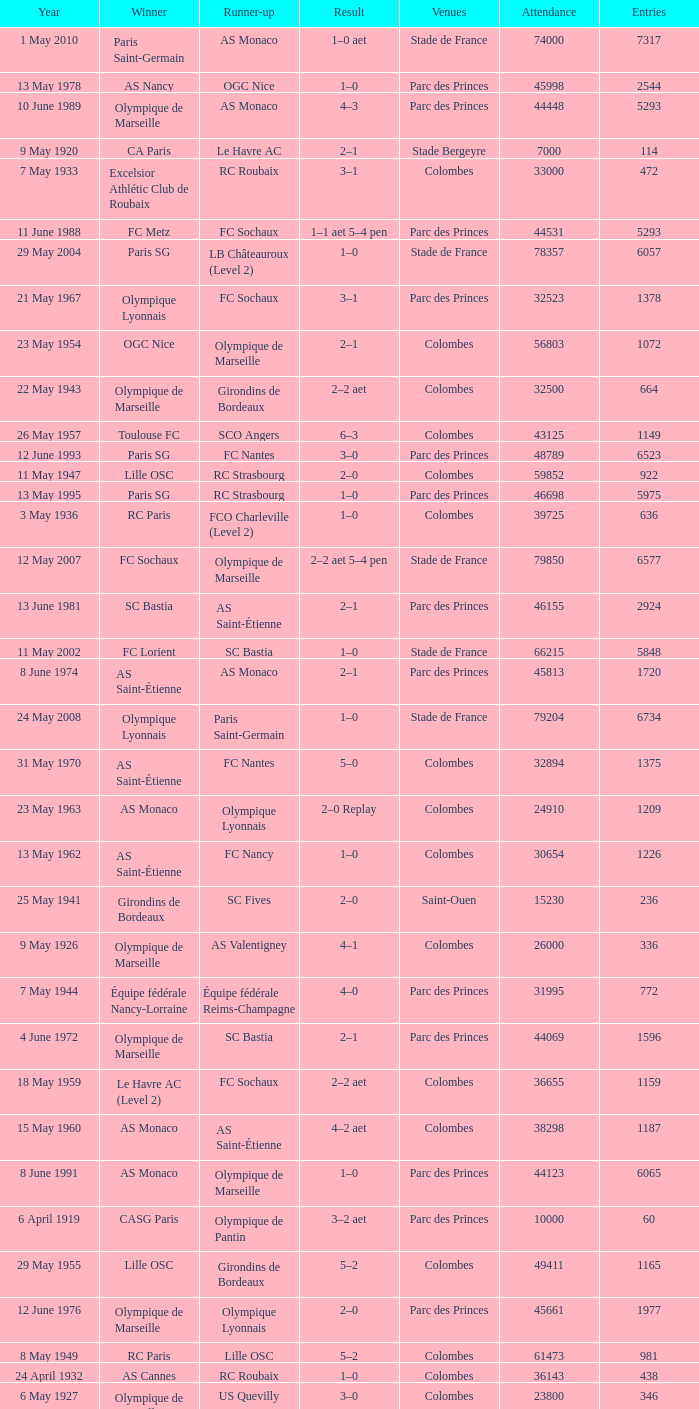Could you parse the entire table as a dict? {'header': ['Year', 'Winner', 'Runner-up', 'Result', 'Venues', 'Attendance', 'Entries'], 'rows': [['1 May 2010', 'Paris Saint-Germain', 'AS Monaco', '1–0 aet', 'Stade de France', '74000', '7317'], ['13 May 1978', 'AS Nancy', 'OGC Nice', '1–0', 'Parc des Princes', '45998', '2544'], ['10 June 1989', 'Olympique de Marseille', 'AS Monaco', '4–3', 'Parc des Princes', '44448', '5293'], ['9 May 1920', 'CA Paris', 'Le Havre AC', '2–1', 'Stade Bergeyre', '7000', '114'], ['7 May 1933', 'Excelsior Athlétic Club de Roubaix', 'RC Roubaix', '3–1', 'Colombes', '33000', '472'], ['11 June 1988', 'FC Metz', 'FC Sochaux', '1–1 aet 5–4 pen', 'Parc des Princes', '44531', '5293'], ['29 May 2004', 'Paris SG', 'LB Châteauroux (Level 2)', '1–0', 'Stade de France', '78357', '6057'], ['21 May 1967', 'Olympique Lyonnais', 'FC Sochaux', '3–1', 'Parc des Princes', '32523', '1378'], ['23 May 1954', 'OGC Nice', 'Olympique de Marseille', '2–1', 'Colombes', '56803', '1072'], ['22 May 1943', 'Olympique de Marseille', 'Girondins de Bordeaux', '2–2 aet', 'Colombes', '32500', '664'], ['26 May 1957', 'Toulouse FC', 'SCO Angers', '6–3', 'Colombes', '43125', '1149'], ['12 June 1993', 'Paris SG', 'FC Nantes', '3–0', 'Parc des Princes', '48789', '6523'], ['11 May 1947', 'Lille OSC', 'RC Strasbourg', '2–0', 'Colombes', '59852', '922'], ['13 May 1995', 'Paris SG', 'RC Strasbourg', '1–0', 'Parc des Princes', '46698', '5975'], ['3 May 1936', 'RC Paris', 'FCO Charleville (Level 2)', '1–0', 'Colombes', '39725', '636'], ['12 May 2007', 'FC Sochaux', 'Olympique de Marseille', '2–2 aet 5–4 pen', 'Stade de France', '79850', '6577'], ['13 June 1981', 'SC Bastia', 'AS Saint-Étienne', '2–1', 'Parc des Princes', '46155', '2924'], ['11 May 2002', 'FC Lorient', 'SC Bastia', '1–0', 'Stade de France', '66215', '5848'], ['8 June 1974', 'AS Saint-Étienne', 'AS Monaco', '2–1', 'Parc des Princes', '45813', '1720'], ['24 May 2008', 'Olympique Lyonnais', 'Paris Saint-Germain', '1–0', 'Stade de France', '79204', '6734'], ['31 May 1970', 'AS Saint-Étienne', 'FC Nantes', '5–0', 'Colombes', '32894', '1375'], ['23 May 1963', 'AS Monaco', 'Olympique Lyonnais', '2–0 Replay', 'Colombes', '24910', '1209'], ['13 May 1962', 'AS Saint-Étienne', 'FC Nancy', '1–0', 'Colombes', '30654', '1226'], ['25 May 1941', 'Girondins de Bordeaux', 'SC Fives', '2–0', 'Saint-Ouen', '15230', '236'], ['9 May 1926', 'Olympique de Marseille', 'AS Valentigney', '4–1', 'Colombes', '26000', '336'], ['7 May 1944', 'Équipe fédérale Nancy-Lorraine', 'Équipe fédérale Reims-Champagne', '4–0', 'Parc des Princes', '31995', '772'], ['4 June 1972', 'Olympique de Marseille', 'SC Bastia', '2–1', 'Parc des Princes', '44069', '1596'], ['18 May 1959', 'Le Havre AC (Level 2)', 'FC Sochaux', '2–2 aet', 'Colombes', '36655', '1159'], ['15 May 1960', 'AS Monaco', 'AS Saint-Étienne', '4–2 aet', 'Colombes', '38298', '1187'], ['8 June 1991', 'AS Monaco', 'Olympique de Marseille', '1–0', 'Parc des Princes', '44123', '6065'], ['6 April 1919', 'CASG Paris', 'Olympique de Pantin', '3–2 aet', 'Parc des Princes', '10000', '60'], ['29 May 1955', 'Lille OSC', 'Girondins de Bordeaux', '5–2', 'Colombes', '49411', '1165'], ['12 June 1976', 'Olympique de Marseille', 'Olympique Lyonnais', '2–0', 'Parc des Princes', '45661', '1977'], ['8 May 1949', 'RC Paris', 'Lille OSC', '5–2', 'Colombes', '61473', '981'], ['24 April 1932', 'AS Cannes', 'RC Roubaix', '1–0', 'Colombes', '36143', '438'], ['6 May 1927', 'Olympique de Marseille', 'US Quevilly', '3–0', 'Colombes', '23800', '346'], ['7 May 1922', 'Red Star', 'Stade Rennais', '2–0', 'Stade Pershing', '25000', '249'], ['14 May 1950', 'Stade de Reims', 'RC Paris', '2–0', 'Colombes', '61722', '977'], ['26 May 2001', 'RC Strasbourg', 'Amiens SC (Level 2)', '0–0 aet 5–4 pen', 'Stade de France', '78641', '6375'], ['10 May 1925', 'CASG Paris', 'FC Rouen', '3–2 Replay', 'Colombes', '18000', '326'], ['14 May 1939', 'RC Paris', 'Lille OSC', '3–1', 'Colombes', '52431', '727'], ['31 May 2003', 'AJ Auxerre', 'Paris SG', '2–1', 'Stade de France', '78316', '5850'], ['18 June 1977', 'AS Saint-Étienne', 'Stade de Reims', '2–1', 'Parc des Princes', '45454', '2084'], ['20 June 1971', 'Stade Rennais', 'Olympique Lyonnais', '1–0', 'Colombes', '46801', '1383'], ['15 May 1999', 'FC Nantes', 'CS Sedan (Level 2)', '1–0', 'Stade de France', '78586', '5957'], ['2 June 1990', 'Montpellier Hérault SC', 'RC Paris', '2–1 aet', 'Parc des Princes', '44067', '5972'], ['22 May 1943', 'Olympique de Marseille', 'Girondins de Bordeaux', '4–0 Replay', 'Colombes', '32212', '664'], ['22 May 1966', 'RC Strasbourg', 'FC Nantes', '1–0', 'Parc des Princes', '36285', '1190'], ['5 May 1940', 'RC Paris', 'Olympique de Marseille', '2–1', 'Parc des Princes', '25969', '778'], ['4 June 2005', 'AJ Auxerre', 'CS Sedan', '2–1', 'Stade de France', '78721', '6263'], ['9 May 2009', 'EA Guingamp (Level 2)', 'Stade Rennais', '2–1', 'Stade de France', '80056', '7246'], ['18 May 1969', 'Olympique de Marseille', 'Girondins de Bordeaux', '2–0', 'Colombes', '39460', '1377'], ['13 April 1924', 'Olympique de Marseille', 'FC Sète', '3–2 aet', 'Stade Pershing', '29000', '325'], ['4 May 1996', 'AJ Auxerre', 'Nîmes Olympique (Level 3)', '2–1', 'Parc des Princes', '44921', '5847'], ['6 May 1951', 'RC Strasbourg', 'Valenciennes FC (Level 2)', '3–0', 'Colombes', '61492', '1010'], ['18 May 1959', 'Le Havre AC (Level 2)', 'FC Sochaux', '3–0 Replay', 'Colombes', '36655', '1159'], ['11 June 1983', 'Paris SG', 'FC Nantes', '3–2', 'Parc des Princes', '46203', '3280'], ['27 May 1956', 'CS Sedan', 'ES Troyes AC', '3–1', 'Colombes', '47258', '1203'], ['15 May 1982', 'Paris SG', 'AS Saint-Étienne', '2–2 aet 6–5 pen', 'Parc des Princes', '46160', '3179'], ['6 May 1945', 'RC Paris', 'Lille OSC', '3–0', 'Colombes', '49983', '510'], ['11 May 1984', 'FC Metz', 'AS Monaco', '2–0 aet', 'Parc des Princes', '45384', '3705'], ['14 June 1975', 'AS Saint-Étienne', 'RC Lens', '2–0', 'Parc des Princes', '44725', '1940'], ['24 April 1921', 'Red Star', 'Olympique de Pantin', '2–1', 'Stade Pershing', '18000', '202'], ['31 May 1953', 'Lille OSC', 'FC Nancy', '2–1', 'Colombes', '58993', '1035'], ['26 May 1965', 'Stade Rennais', 'CS Sedan', '3–1 Replay', 'Parc des Princes', '26792', '1183'], ['29 April 2006', 'Paris Saint-Germain', 'Olympique de Marseille', '2–1', 'Stade de France', '79797', '6394'], ['12 May 1968', 'AS Saint-Étienne', 'Girondins de Bordeaux', '2–1', 'Colombes', '33959', '1378'], ['9 May 1937', 'FC Sochaux', 'RC Strasbourg', '2–1', 'Colombes', '39538', '658'], ['5 May 1929', 'Montpellier Hérault SC', 'FC Sète', '2–0', 'Colombes', '25000', '380'], ['28 April 2012', 'Olympique Lyonnais', 'US Quevilly (Level 3)', '1–0', 'Stade de France', '76293', '7422'], ['10 May 1948', 'Lille OSC', 'RC Lens (Level 2)', '3–2', 'Colombes', '60739', '933'], ['18 May 1958', 'Stade de Reims', 'Nîmes Olympique', '3–1', 'Colombes', '56523', '1163'], ['14 May 1994', 'AJ Auxerre', 'Montpellier HSC', '3–0', 'Parc des Princes', '45189', '6261'], ['7 May 2000', 'FC Nantes', 'Calais RUFC (Level 4)', '2–1', 'Stade de France', '78717', '6096'], ['27 April 1930', 'FC Sète', 'RC Paris', '3–1 aet', 'Colombes', '35000', '408'], ['6 May 1928', 'Red Star', 'CA Paris', '3–1', 'Colombes', '30000', '336'], ['23 May 1963', 'AS Monaco', 'Olympique Lyonnais', '0–0 aet', 'Colombes', '32923', '1209'], ['6 May 1923', 'Red Star', 'FC Sète', '4–2', 'Stade Pershing', '20000', '304'], ['26 May 1946', 'Lille OSC', 'Red Star', '4–2', 'Colombes', '59692', '811'], ['7 May 1961', 'CS Sedan', 'Nîmes Olympique', '3–1', 'Colombes', '39070', '1193'], ['17 June 1973', 'Olympique Lyonnais', 'FC Nantes', '2–1', 'Parc des Princes', '45734', '1596'], ['10 May 1997', 'OGC Nice', 'En Avant de Guingamp', '1–1 aet 4–3 pen', 'Parc des Princes', '44131', '5986'], ['5 May 1918', 'Olympique de Pantin', 'FC Lyon', '3–0', 'Rue Olivier-de-Serres', '2000', '48'], ['4 May 1952', 'OGC Nice', 'Girondins de Bordeaux', '5–3', 'Colombes', '61485', '1024'], ['10 May 1925', 'CASG Paris', 'FC Rouen', '1–1 aet', 'Colombes', '18000', '326'], ['3 May 1931', 'Club Français', 'Montpellier Hérault SC', '3–0', 'Colombes', '30000', '423'], ['7 June 1980', 'AS Monaco', 'US Orléans (Level 2)', '3–1', 'Parc des Princes', '46136', '2473'], ['26 May 1965', 'Stade Rennais', 'CS Sedan', '2–2 aet', 'Parc des Princes', '36789', '1183'], ['6 May 1934', 'FC Sète', 'Olympique de Marseille', '2–1', 'Colombes', '40600', '540'], ['5 May 1935', 'Olympique de Marseille', 'Stade Rennais', '3–0', 'Colombes', '40008', '567'], ['8 June 1985', 'AS Monaco', 'Paris SG', '1–0', 'Parc des Princes', '45711', '3983'], ['14 May 2011', 'Lille', 'Paris Saint-Germain', '1–0', 'Stade de France', '79000', '7449'], ['10 May 1964', 'Olympique Lyonnais', 'Girondins de Bordeaux', '2–0', 'Colombes', '32777', '1203'], ['17 May 1942', 'Red Star', 'FC Sète', '2–0', 'Colombes', '40000', '469'], ['10 June 1987', 'Girondins de Bordeaux', 'Olympique de Marseille', '2–0', 'Parc des Princes', '45145', '4964'], ['30 April 1986', 'Girondins de Bordeaux', 'Olympique de Marseille', '2–1 aet', 'Parc des Princes', '45429', '4117'], ['16 June 1979', 'FC Nantes', 'AJ Auxerre (Level 2)', '4–1 aet', 'Parc des Princes', '46070', '2473'], ['2 May 1998', 'Paris SG', 'RC Lens', '2–1', 'Stade de France', '78265', '6106'], ['8 May 1938', 'Olympique de Marseille', 'FC Metz', '2–1 aet', 'Parc des Princes', '33044', '679']]} What is the fewest recorded entrants against paris saint-germain? 6394.0. 